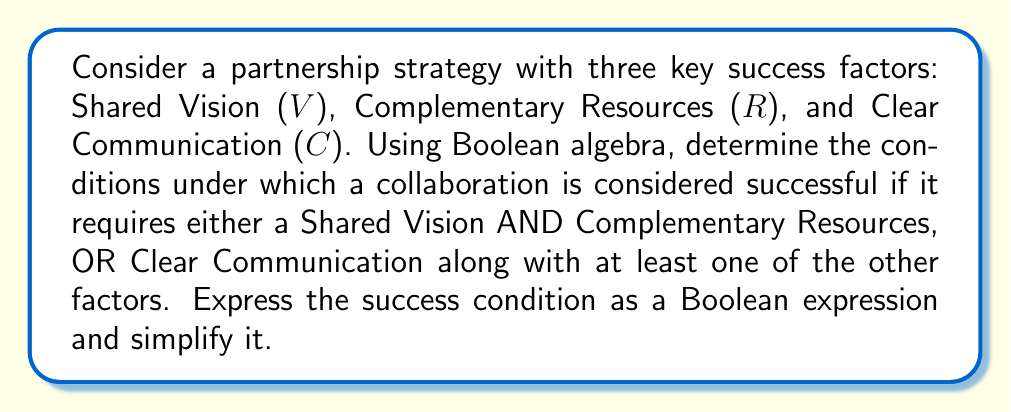Solve this math problem. Let's approach this step-by-step:

1) First, we need to translate the given conditions into a Boolean expression:
   - Shared Vision AND Complementary Resources: $V \land R$
   - Clear Communication with at least one other factor: $C \land (V \lor R)$
   
2) The overall success condition is the OR of these two conditions:
   $$(V \land R) \lor (C \land (V \lor R))$$

3) Now, let's simplify this expression using Boolean algebra laws:
   
   $$(V \land R) \lor (C \land (V \lor R))$$
   
   $= (V \land R) \lor (CV \lor CR)$  (Distributive law)
   
   $= V(R \lor C) \lor CR$  (Distributive law)
   
   $= VR \lor VC \lor CR$  (Distributive law)

4) This simplified expression, $VR \lor VC \lor CR$, represents the conditions for a successful collaboration in our model.

5) Interpreting this result:
   - The collaboration is successful if there is:
     a) Shared Vision AND Complementary Resources (VR), OR
     b) Shared Vision AND Clear Communication (VC), OR
     c) Complementary Resources AND Clear Communication (CR)
Answer: $VR \lor VC \lor CR$ 